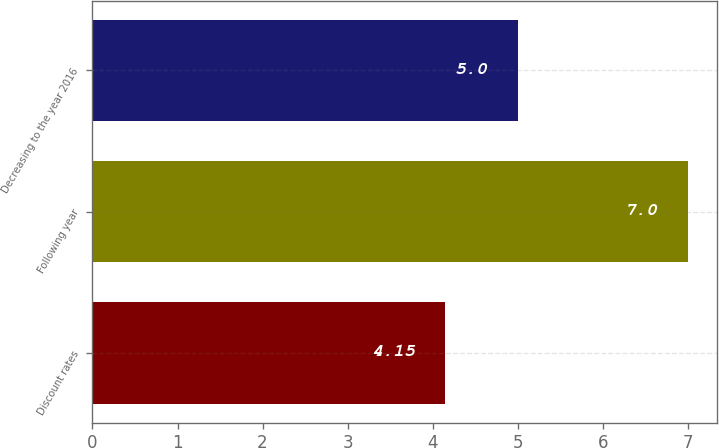<chart> <loc_0><loc_0><loc_500><loc_500><bar_chart><fcel>Discount rates<fcel>Following year<fcel>Decreasing to the year 2016<nl><fcel>4.15<fcel>7<fcel>5<nl></chart> 